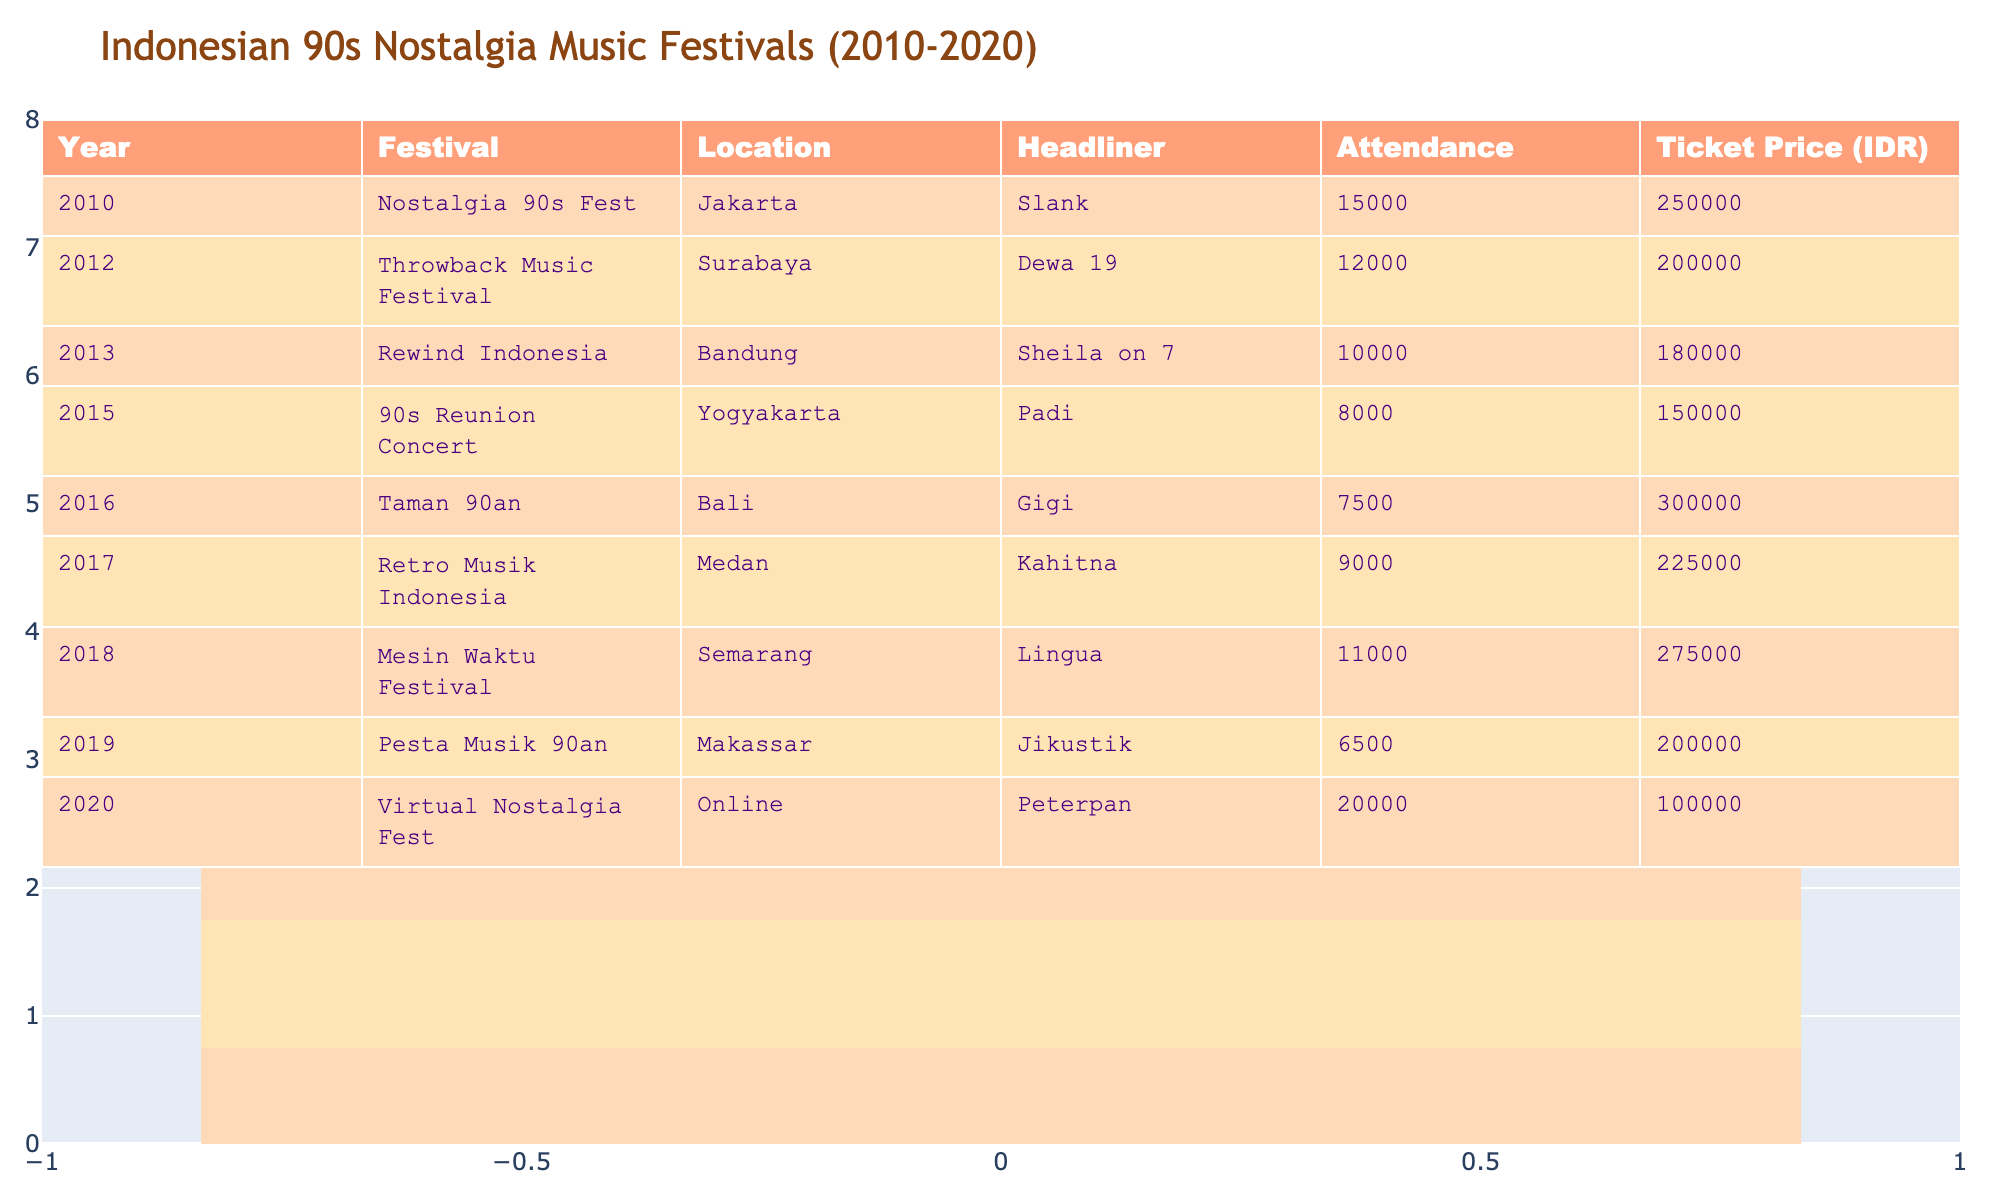What was the headliner for the 2013 festival? The 2013 festival was "Rewind Indonesia" and its headliner was "Sheila on 7" as indicated in the Headliner column for that year.
Answer: Sheila on 7 Which festival had the highest attendance? To find the highest attendance, we look at the Attendance column and see that "Virtual Nostalgia Fest" in 2020 had 20,000 attendees, which is the highest figure compared to other years.
Answer: Virtual Nostalgia Fest What is the average ticket price across all festivals listed in the table? First, sum the ticket prices: 250000 + 200000 + 180000 + 150000 + 300000 + 225000 + 275000 + 200000 + 100000 = 1880000. There are 9 festivals, so the average ticket price is 1880000 divided by 9, which equals approximately 208888.89. Rounding gives 208889.
Answer: 208889 Was "Jikustik" ever a headliner in a festival during these years? Looking at the headliner column, "Jikustik" was the headliner for the 2019 festival called "Pesta Musik 90an." Therefore, the answer is Yes.
Answer: Yes How much did the attendance drop from the "Nostalgia 90s Fest" in 2010 to the "90s Reunion Concert" in 2015? The attendance for "Nostalgia 90s Fest" in 2010 was 15000 and for "90s Reunion Concert" in 2015, it was 8000. The drop is 15000 - 8000 = 7000.
Answer: 7000 Which location hosted the festival with the lowest attendance? The festival with the lowest attendance is the "Pesta Musik 90an" in Makassar with an attendance of 6500, as seen in the Attendance column.
Answer: Makassar Did any festival have a ticket price higher than 300,000 IDR? Checking the Ticket Price column, no festival exceeds 300,000 IDR since the highest ticket price is 300,000 IDR, set by "Taman 90an" in 2016 whereas none are listed above that. Therefore, the answer is No.
Answer: No What was the total attendance for all festivals in 2018 and 2019 combined? The attendance for "Mesin Waktu Festival" in 2018 was 11000 and for "Pesta Musik 90an" in 2019 it was 6500. Adding these together gives 11000 + 6500 = 17500.
Answer: 17500 Which headliner had a ticket price of exactly 200,000 IDR? Referring to the Ticket Price column, the headliner for the 2012 "Throwback Music Festival," which had a ticket price of 200,000 IDR, was "Dewa 19." Therefore, the answer is Dewa 19.
Answer: Dewa 19 What was the difference in attendance between the festival with the highest attendance and the one with the lowest? The festival with the highest attendance is "Virtual Nostalgia Fest" in 2020 with 20,000 attendees, and the lowest is "Pesta Musik 90an" in 2019 with 6,500 attendees. The difference is 20,000 - 6,500 = 13,500.
Answer: 13500 Which festival in 2016 had a ticket price of 300,000 IDR and what was its headliner? The festival in 2016 is "Taman 90an," and its headliner was "Gigi" as per their record in the Headliners column.
Answer: Taman 90an, Gigi 